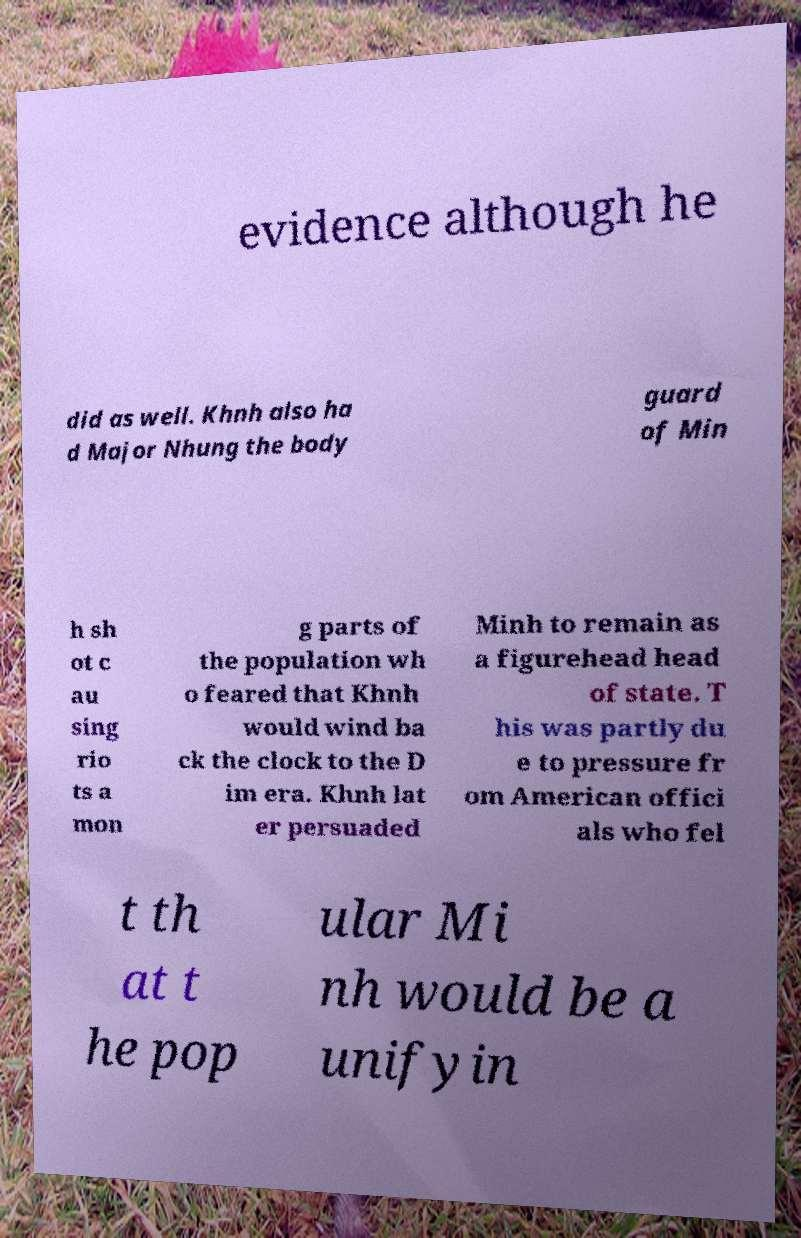What messages or text are displayed in this image? I need them in a readable, typed format. evidence although he did as well. Khnh also ha d Major Nhung the body guard of Min h sh ot c au sing rio ts a mon g parts of the population wh o feared that Khnh would wind ba ck the clock to the D im era. Khnh lat er persuaded Minh to remain as a figurehead head of state. T his was partly du e to pressure fr om American offici als who fel t th at t he pop ular Mi nh would be a unifyin 